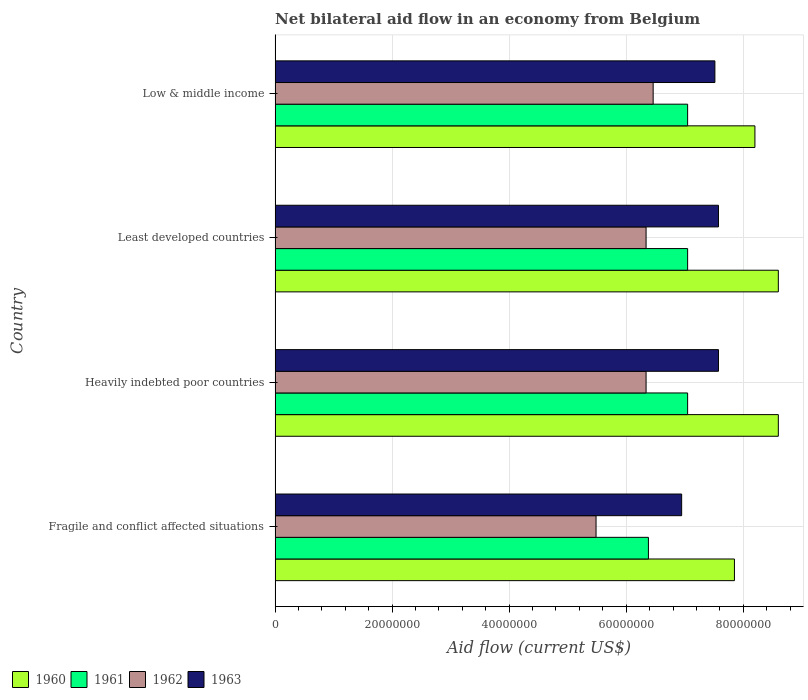How many different coloured bars are there?
Your response must be concise. 4. Are the number of bars per tick equal to the number of legend labels?
Make the answer very short. Yes. How many bars are there on the 4th tick from the bottom?
Your response must be concise. 4. What is the label of the 1st group of bars from the top?
Provide a succinct answer. Low & middle income. What is the net bilateral aid flow in 1963 in Heavily indebted poor countries?
Ensure brevity in your answer.  7.58e+07. Across all countries, what is the maximum net bilateral aid flow in 1960?
Provide a short and direct response. 8.60e+07. Across all countries, what is the minimum net bilateral aid flow in 1961?
Provide a short and direct response. 6.38e+07. In which country was the net bilateral aid flow in 1963 maximum?
Offer a very short reply. Heavily indebted poor countries. In which country was the net bilateral aid flow in 1963 minimum?
Ensure brevity in your answer.  Fragile and conflict affected situations. What is the total net bilateral aid flow in 1963 in the graph?
Offer a terse response. 2.96e+08. What is the difference between the net bilateral aid flow in 1961 in Least developed countries and that in Low & middle income?
Your answer should be very brief. 0. What is the difference between the net bilateral aid flow in 1961 in Fragile and conflict affected situations and the net bilateral aid flow in 1963 in Low & middle income?
Your answer should be compact. -1.14e+07. What is the average net bilateral aid flow in 1960 per country?
Provide a short and direct response. 8.31e+07. What is the difference between the net bilateral aid flow in 1962 and net bilateral aid flow in 1960 in Least developed countries?
Make the answer very short. -2.26e+07. What is the ratio of the net bilateral aid flow in 1962 in Heavily indebted poor countries to that in Low & middle income?
Offer a terse response. 0.98. Is the net bilateral aid flow in 1960 in Fragile and conflict affected situations less than that in Least developed countries?
Provide a short and direct response. Yes. What is the difference between the highest and the second highest net bilateral aid flow in 1962?
Your answer should be very brief. 1.21e+06. What is the difference between the highest and the lowest net bilateral aid flow in 1963?
Your response must be concise. 6.29e+06. In how many countries, is the net bilateral aid flow in 1960 greater than the average net bilateral aid flow in 1960 taken over all countries?
Ensure brevity in your answer.  2. What does the 2nd bar from the bottom in Low & middle income represents?
Make the answer very short. 1961. Is it the case that in every country, the sum of the net bilateral aid flow in 1963 and net bilateral aid flow in 1960 is greater than the net bilateral aid flow in 1961?
Ensure brevity in your answer.  Yes. How many bars are there?
Give a very brief answer. 16. Are all the bars in the graph horizontal?
Offer a terse response. Yes. How many countries are there in the graph?
Give a very brief answer. 4. Are the values on the major ticks of X-axis written in scientific E-notation?
Ensure brevity in your answer.  No. Does the graph contain any zero values?
Ensure brevity in your answer.  No. How many legend labels are there?
Provide a succinct answer. 4. What is the title of the graph?
Your answer should be compact. Net bilateral aid flow in an economy from Belgium. What is the label or title of the X-axis?
Your response must be concise. Aid flow (current US$). What is the Aid flow (current US$) in 1960 in Fragile and conflict affected situations?
Ensure brevity in your answer.  7.85e+07. What is the Aid flow (current US$) of 1961 in Fragile and conflict affected situations?
Give a very brief answer. 6.38e+07. What is the Aid flow (current US$) of 1962 in Fragile and conflict affected situations?
Your answer should be compact. 5.48e+07. What is the Aid flow (current US$) of 1963 in Fragile and conflict affected situations?
Offer a terse response. 6.95e+07. What is the Aid flow (current US$) in 1960 in Heavily indebted poor countries?
Provide a short and direct response. 8.60e+07. What is the Aid flow (current US$) in 1961 in Heavily indebted poor countries?
Offer a very short reply. 7.05e+07. What is the Aid flow (current US$) in 1962 in Heavily indebted poor countries?
Give a very brief answer. 6.34e+07. What is the Aid flow (current US$) in 1963 in Heavily indebted poor countries?
Offer a terse response. 7.58e+07. What is the Aid flow (current US$) of 1960 in Least developed countries?
Provide a succinct answer. 8.60e+07. What is the Aid flow (current US$) in 1961 in Least developed countries?
Your response must be concise. 7.05e+07. What is the Aid flow (current US$) in 1962 in Least developed countries?
Ensure brevity in your answer.  6.34e+07. What is the Aid flow (current US$) of 1963 in Least developed countries?
Ensure brevity in your answer.  7.58e+07. What is the Aid flow (current US$) in 1960 in Low & middle income?
Ensure brevity in your answer.  8.20e+07. What is the Aid flow (current US$) in 1961 in Low & middle income?
Offer a very short reply. 7.05e+07. What is the Aid flow (current US$) in 1962 in Low & middle income?
Give a very brief answer. 6.46e+07. What is the Aid flow (current US$) of 1963 in Low & middle income?
Offer a very short reply. 7.52e+07. Across all countries, what is the maximum Aid flow (current US$) in 1960?
Provide a short and direct response. 8.60e+07. Across all countries, what is the maximum Aid flow (current US$) of 1961?
Your response must be concise. 7.05e+07. Across all countries, what is the maximum Aid flow (current US$) of 1962?
Ensure brevity in your answer.  6.46e+07. Across all countries, what is the maximum Aid flow (current US$) of 1963?
Your answer should be compact. 7.58e+07. Across all countries, what is the minimum Aid flow (current US$) of 1960?
Offer a terse response. 7.85e+07. Across all countries, what is the minimum Aid flow (current US$) of 1961?
Make the answer very short. 6.38e+07. Across all countries, what is the minimum Aid flow (current US$) in 1962?
Offer a very short reply. 5.48e+07. Across all countries, what is the minimum Aid flow (current US$) of 1963?
Ensure brevity in your answer.  6.95e+07. What is the total Aid flow (current US$) in 1960 in the graph?
Provide a succinct answer. 3.32e+08. What is the total Aid flow (current US$) of 1961 in the graph?
Offer a very short reply. 2.75e+08. What is the total Aid flow (current US$) in 1962 in the graph?
Offer a terse response. 2.46e+08. What is the total Aid flow (current US$) of 1963 in the graph?
Your answer should be very brief. 2.96e+08. What is the difference between the Aid flow (current US$) in 1960 in Fragile and conflict affected situations and that in Heavily indebted poor countries?
Give a very brief answer. -7.50e+06. What is the difference between the Aid flow (current US$) of 1961 in Fragile and conflict affected situations and that in Heavily indebted poor countries?
Offer a terse response. -6.70e+06. What is the difference between the Aid flow (current US$) in 1962 in Fragile and conflict affected situations and that in Heavily indebted poor countries?
Make the answer very short. -8.55e+06. What is the difference between the Aid flow (current US$) in 1963 in Fragile and conflict affected situations and that in Heavily indebted poor countries?
Provide a succinct answer. -6.29e+06. What is the difference between the Aid flow (current US$) in 1960 in Fragile and conflict affected situations and that in Least developed countries?
Make the answer very short. -7.50e+06. What is the difference between the Aid flow (current US$) in 1961 in Fragile and conflict affected situations and that in Least developed countries?
Your answer should be very brief. -6.70e+06. What is the difference between the Aid flow (current US$) of 1962 in Fragile and conflict affected situations and that in Least developed countries?
Offer a terse response. -8.55e+06. What is the difference between the Aid flow (current US$) in 1963 in Fragile and conflict affected situations and that in Least developed countries?
Keep it short and to the point. -6.29e+06. What is the difference between the Aid flow (current US$) of 1960 in Fragile and conflict affected situations and that in Low & middle income?
Offer a very short reply. -3.50e+06. What is the difference between the Aid flow (current US$) in 1961 in Fragile and conflict affected situations and that in Low & middle income?
Your answer should be compact. -6.70e+06. What is the difference between the Aid flow (current US$) of 1962 in Fragile and conflict affected situations and that in Low & middle income?
Your answer should be very brief. -9.76e+06. What is the difference between the Aid flow (current US$) in 1963 in Fragile and conflict affected situations and that in Low & middle income?
Offer a very short reply. -5.68e+06. What is the difference between the Aid flow (current US$) of 1960 in Heavily indebted poor countries and that in Least developed countries?
Give a very brief answer. 0. What is the difference between the Aid flow (current US$) in 1961 in Heavily indebted poor countries and that in Least developed countries?
Provide a succinct answer. 0. What is the difference between the Aid flow (current US$) in 1962 in Heavily indebted poor countries and that in Low & middle income?
Provide a succinct answer. -1.21e+06. What is the difference between the Aid flow (current US$) of 1963 in Heavily indebted poor countries and that in Low & middle income?
Provide a short and direct response. 6.10e+05. What is the difference between the Aid flow (current US$) in 1960 in Least developed countries and that in Low & middle income?
Offer a terse response. 4.00e+06. What is the difference between the Aid flow (current US$) in 1962 in Least developed countries and that in Low & middle income?
Offer a very short reply. -1.21e+06. What is the difference between the Aid flow (current US$) of 1963 in Least developed countries and that in Low & middle income?
Make the answer very short. 6.10e+05. What is the difference between the Aid flow (current US$) in 1960 in Fragile and conflict affected situations and the Aid flow (current US$) in 1962 in Heavily indebted poor countries?
Your answer should be very brief. 1.51e+07. What is the difference between the Aid flow (current US$) of 1960 in Fragile and conflict affected situations and the Aid flow (current US$) of 1963 in Heavily indebted poor countries?
Provide a short and direct response. 2.73e+06. What is the difference between the Aid flow (current US$) in 1961 in Fragile and conflict affected situations and the Aid flow (current US$) in 1962 in Heavily indebted poor countries?
Offer a very short reply. 4.00e+05. What is the difference between the Aid flow (current US$) in 1961 in Fragile and conflict affected situations and the Aid flow (current US$) in 1963 in Heavily indebted poor countries?
Offer a very short reply. -1.20e+07. What is the difference between the Aid flow (current US$) in 1962 in Fragile and conflict affected situations and the Aid flow (current US$) in 1963 in Heavily indebted poor countries?
Your answer should be very brief. -2.09e+07. What is the difference between the Aid flow (current US$) of 1960 in Fragile and conflict affected situations and the Aid flow (current US$) of 1962 in Least developed countries?
Give a very brief answer. 1.51e+07. What is the difference between the Aid flow (current US$) of 1960 in Fragile and conflict affected situations and the Aid flow (current US$) of 1963 in Least developed countries?
Ensure brevity in your answer.  2.73e+06. What is the difference between the Aid flow (current US$) of 1961 in Fragile and conflict affected situations and the Aid flow (current US$) of 1963 in Least developed countries?
Your response must be concise. -1.20e+07. What is the difference between the Aid flow (current US$) of 1962 in Fragile and conflict affected situations and the Aid flow (current US$) of 1963 in Least developed countries?
Offer a terse response. -2.09e+07. What is the difference between the Aid flow (current US$) of 1960 in Fragile and conflict affected situations and the Aid flow (current US$) of 1962 in Low & middle income?
Your answer should be very brief. 1.39e+07. What is the difference between the Aid flow (current US$) in 1960 in Fragile and conflict affected situations and the Aid flow (current US$) in 1963 in Low & middle income?
Keep it short and to the point. 3.34e+06. What is the difference between the Aid flow (current US$) in 1961 in Fragile and conflict affected situations and the Aid flow (current US$) in 1962 in Low & middle income?
Keep it short and to the point. -8.10e+05. What is the difference between the Aid flow (current US$) in 1961 in Fragile and conflict affected situations and the Aid flow (current US$) in 1963 in Low & middle income?
Make the answer very short. -1.14e+07. What is the difference between the Aid flow (current US$) in 1962 in Fragile and conflict affected situations and the Aid flow (current US$) in 1963 in Low & middle income?
Offer a very short reply. -2.03e+07. What is the difference between the Aid flow (current US$) of 1960 in Heavily indebted poor countries and the Aid flow (current US$) of 1961 in Least developed countries?
Provide a succinct answer. 1.55e+07. What is the difference between the Aid flow (current US$) in 1960 in Heavily indebted poor countries and the Aid flow (current US$) in 1962 in Least developed countries?
Provide a succinct answer. 2.26e+07. What is the difference between the Aid flow (current US$) of 1960 in Heavily indebted poor countries and the Aid flow (current US$) of 1963 in Least developed countries?
Provide a short and direct response. 1.02e+07. What is the difference between the Aid flow (current US$) of 1961 in Heavily indebted poor countries and the Aid flow (current US$) of 1962 in Least developed countries?
Provide a succinct answer. 7.10e+06. What is the difference between the Aid flow (current US$) in 1961 in Heavily indebted poor countries and the Aid flow (current US$) in 1963 in Least developed countries?
Your response must be concise. -5.27e+06. What is the difference between the Aid flow (current US$) of 1962 in Heavily indebted poor countries and the Aid flow (current US$) of 1963 in Least developed countries?
Make the answer very short. -1.24e+07. What is the difference between the Aid flow (current US$) in 1960 in Heavily indebted poor countries and the Aid flow (current US$) in 1961 in Low & middle income?
Offer a very short reply. 1.55e+07. What is the difference between the Aid flow (current US$) of 1960 in Heavily indebted poor countries and the Aid flow (current US$) of 1962 in Low & middle income?
Your response must be concise. 2.14e+07. What is the difference between the Aid flow (current US$) of 1960 in Heavily indebted poor countries and the Aid flow (current US$) of 1963 in Low & middle income?
Provide a succinct answer. 1.08e+07. What is the difference between the Aid flow (current US$) of 1961 in Heavily indebted poor countries and the Aid flow (current US$) of 1962 in Low & middle income?
Provide a short and direct response. 5.89e+06. What is the difference between the Aid flow (current US$) in 1961 in Heavily indebted poor countries and the Aid flow (current US$) in 1963 in Low & middle income?
Offer a terse response. -4.66e+06. What is the difference between the Aid flow (current US$) in 1962 in Heavily indebted poor countries and the Aid flow (current US$) in 1963 in Low & middle income?
Provide a short and direct response. -1.18e+07. What is the difference between the Aid flow (current US$) of 1960 in Least developed countries and the Aid flow (current US$) of 1961 in Low & middle income?
Make the answer very short. 1.55e+07. What is the difference between the Aid flow (current US$) of 1960 in Least developed countries and the Aid flow (current US$) of 1962 in Low & middle income?
Offer a very short reply. 2.14e+07. What is the difference between the Aid flow (current US$) of 1960 in Least developed countries and the Aid flow (current US$) of 1963 in Low & middle income?
Provide a short and direct response. 1.08e+07. What is the difference between the Aid flow (current US$) of 1961 in Least developed countries and the Aid flow (current US$) of 1962 in Low & middle income?
Keep it short and to the point. 5.89e+06. What is the difference between the Aid flow (current US$) in 1961 in Least developed countries and the Aid flow (current US$) in 1963 in Low & middle income?
Your answer should be very brief. -4.66e+06. What is the difference between the Aid flow (current US$) of 1962 in Least developed countries and the Aid flow (current US$) of 1963 in Low & middle income?
Your response must be concise. -1.18e+07. What is the average Aid flow (current US$) in 1960 per country?
Offer a very short reply. 8.31e+07. What is the average Aid flow (current US$) in 1961 per country?
Provide a short and direct response. 6.88e+07. What is the average Aid flow (current US$) of 1962 per country?
Give a very brief answer. 6.16e+07. What is the average Aid flow (current US$) in 1963 per country?
Provide a short and direct response. 7.40e+07. What is the difference between the Aid flow (current US$) in 1960 and Aid flow (current US$) in 1961 in Fragile and conflict affected situations?
Make the answer very short. 1.47e+07. What is the difference between the Aid flow (current US$) of 1960 and Aid flow (current US$) of 1962 in Fragile and conflict affected situations?
Your answer should be very brief. 2.36e+07. What is the difference between the Aid flow (current US$) of 1960 and Aid flow (current US$) of 1963 in Fragile and conflict affected situations?
Ensure brevity in your answer.  9.02e+06. What is the difference between the Aid flow (current US$) in 1961 and Aid flow (current US$) in 1962 in Fragile and conflict affected situations?
Provide a short and direct response. 8.95e+06. What is the difference between the Aid flow (current US$) in 1961 and Aid flow (current US$) in 1963 in Fragile and conflict affected situations?
Your response must be concise. -5.68e+06. What is the difference between the Aid flow (current US$) of 1962 and Aid flow (current US$) of 1963 in Fragile and conflict affected situations?
Offer a very short reply. -1.46e+07. What is the difference between the Aid flow (current US$) of 1960 and Aid flow (current US$) of 1961 in Heavily indebted poor countries?
Give a very brief answer. 1.55e+07. What is the difference between the Aid flow (current US$) of 1960 and Aid flow (current US$) of 1962 in Heavily indebted poor countries?
Make the answer very short. 2.26e+07. What is the difference between the Aid flow (current US$) in 1960 and Aid flow (current US$) in 1963 in Heavily indebted poor countries?
Ensure brevity in your answer.  1.02e+07. What is the difference between the Aid flow (current US$) in 1961 and Aid flow (current US$) in 1962 in Heavily indebted poor countries?
Offer a very short reply. 7.10e+06. What is the difference between the Aid flow (current US$) of 1961 and Aid flow (current US$) of 1963 in Heavily indebted poor countries?
Provide a succinct answer. -5.27e+06. What is the difference between the Aid flow (current US$) in 1962 and Aid flow (current US$) in 1963 in Heavily indebted poor countries?
Your response must be concise. -1.24e+07. What is the difference between the Aid flow (current US$) of 1960 and Aid flow (current US$) of 1961 in Least developed countries?
Offer a very short reply. 1.55e+07. What is the difference between the Aid flow (current US$) of 1960 and Aid flow (current US$) of 1962 in Least developed countries?
Make the answer very short. 2.26e+07. What is the difference between the Aid flow (current US$) of 1960 and Aid flow (current US$) of 1963 in Least developed countries?
Offer a very short reply. 1.02e+07. What is the difference between the Aid flow (current US$) in 1961 and Aid flow (current US$) in 1962 in Least developed countries?
Give a very brief answer. 7.10e+06. What is the difference between the Aid flow (current US$) in 1961 and Aid flow (current US$) in 1963 in Least developed countries?
Give a very brief answer. -5.27e+06. What is the difference between the Aid flow (current US$) in 1962 and Aid flow (current US$) in 1963 in Least developed countries?
Offer a terse response. -1.24e+07. What is the difference between the Aid flow (current US$) in 1960 and Aid flow (current US$) in 1961 in Low & middle income?
Ensure brevity in your answer.  1.15e+07. What is the difference between the Aid flow (current US$) in 1960 and Aid flow (current US$) in 1962 in Low & middle income?
Your response must be concise. 1.74e+07. What is the difference between the Aid flow (current US$) of 1960 and Aid flow (current US$) of 1963 in Low & middle income?
Provide a succinct answer. 6.84e+06. What is the difference between the Aid flow (current US$) of 1961 and Aid flow (current US$) of 1962 in Low & middle income?
Provide a short and direct response. 5.89e+06. What is the difference between the Aid flow (current US$) of 1961 and Aid flow (current US$) of 1963 in Low & middle income?
Your response must be concise. -4.66e+06. What is the difference between the Aid flow (current US$) of 1962 and Aid flow (current US$) of 1963 in Low & middle income?
Keep it short and to the point. -1.06e+07. What is the ratio of the Aid flow (current US$) of 1960 in Fragile and conflict affected situations to that in Heavily indebted poor countries?
Keep it short and to the point. 0.91. What is the ratio of the Aid flow (current US$) in 1961 in Fragile and conflict affected situations to that in Heavily indebted poor countries?
Your response must be concise. 0.91. What is the ratio of the Aid flow (current US$) of 1962 in Fragile and conflict affected situations to that in Heavily indebted poor countries?
Offer a terse response. 0.87. What is the ratio of the Aid flow (current US$) in 1963 in Fragile and conflict affected situations to that in Heavily indebted poor countries?
Give a very brief answer. 0.92. What is the ratio of the Aid flow (current US$) in 1960 in Fragile and conflict affected situations to that in Least developed countries?
Ensure brevity in your answer.  0.91. What is the ratio of the Aid flow (current US$) of 1961 in Fragile and conflict affected situations to that in Least developed countries?
Give a very brief answer. 0.91. What is the ratio of the Aid flow (current US$) of 1962 in Fragile and conflict affected situations to that in Least developed countries?
Keep it short and to the point. 0.87. What is the ratio of the Aid flow (current US$) of 1963 in Fragile and conflict affected situations to that in Least developed countries?
Provide a succinct answer. 0.92. What is the ratio of the Aid flow (current US$) of 1960 in Fragile and conflict affected situations to that in Low & middle income?
Provide a succinct answer. 0.96. What is the ratio of the Aid flow (current US$) of 1961 in Fragile and conflict affected situations to that in Low & middle income?
Give a very brief answer. 0.91. What is the ratio of the Aid flow (current US$) of 1962 in Fragile and conflict affected situations to that in Low & middle income?
Offer a very short reply. 0.85. What is the ratio of the Aid flow (current US$) in 1963 in Fragile and conflict affected situations to that in Low & middle income?
Offer a terse response. 0.92. What is the ratio of the Aid flow (current US$) of 1960 in Heavily indebted poor countries to that in Low & middle income?
Provide a short and direct response. 1.05. What is the ratio of the Aid flow (current US$) of 1962 in Heavily indebted poor countries to that in Low & middle income?
Your answer should be compact. 0.98. What is the ratio of the Aid flow (current US$) in 1963 in Heavily indebted poor countries to that in Low & middle income?
Your answer should be compact. 1.01. What is the ratio of the Aid flow (current US$) in 1960 in Least developed countries to that in Low & middle income?
Provide a short and direct response. 1.05. What is the ratio of the Aid flow (current US$) of 1962 in Least developed countries to that in Low & middle income?
Give a very brief answer. 0.98. What is the ratio of the Aid flow (current US$) in 1963 in Least developed countries to that in Low & middle income?
Give a very brief answer. 1.01. What is the difference between the highest and the second highest Aid flow (current US$) of 1961?
Ensure brevity in your answer.  0. What is the difference between the highest and the second highest Aid flow (current US$) of 1962?
Your response must be concise. 1.21e+06. What is the difference between the highest and the lowest Aid flow (current US$) in 1960?
Your response must be concise. 7.50e+06. What is the difference between the highest and the lowest Aid flow (current US$) of 1961?
Provide a succinct answer. 6.70e+06. What is the difference between the highest and the lowest Aid flow (current US$) of 1962?
Your answer should be compact. 9.76e+06. What is the difference between the highest and the lowest Aid flow (current US$) of 1963?
Your answer should be very brief. 6.29e+06. 